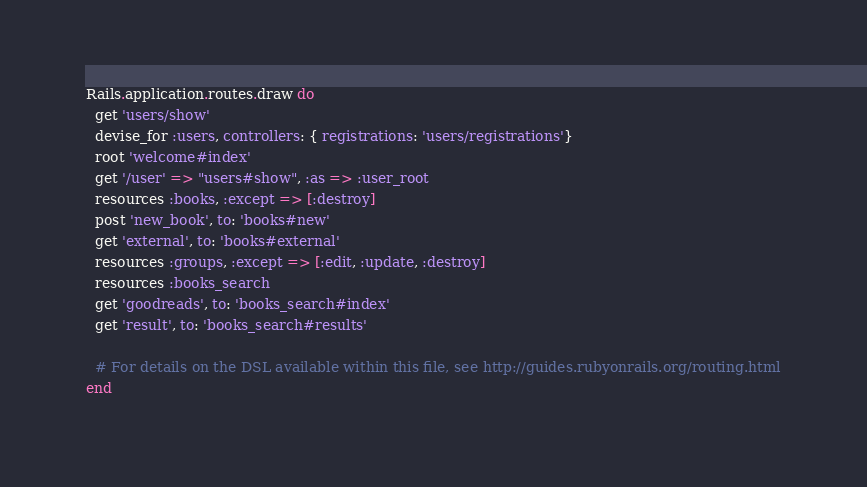<code> <loc_0><loc_0><loc_500><loc_500><_Ruby_>Rails.application.routes.draw do
  get 'users/show'
  devise_for :users, controllers: { registrations: 'users/registrations'}
  root 'welcome#index'
  get '/user' => "users#show", :as => :user_root
  resources :books, :except => [:destroy]
  post 'new_book', to: 'books#new'
  get 'external', to: 'books#external'
  resources :groups, :except => [:edit, :update, :destroy]
  resources :books_search
  get 'goodreads', to: 'books_search#index'
  get 'result', to: 'books_search#results'
 
  # For details on the DSL available within this file, see http://guides.rubyonrails.org/routing.html
end
</code> 